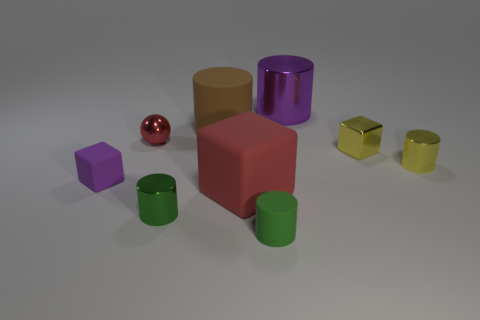Subtract all brown cylinders. How many cylinders are left? 4 Subtract all purple cylinders. How many cylinders are left? 4 Subtract all red cylinders. Subtract all yellow balls. How many cylinders are left? 5 Add 1 rubber cylinders. How many objects exist? 10 Subtract all blocks. How many objects are left? 6 Add 8 tiny spheres. How many tiny spheres exist? 9 Subtract 0 blue blocks. How many objects are left? 9 Subtract all small purple spheres. Subtract all purple matte cubes. How many objects are left? 8 Add 8 yellow objects. How many yellow objects are left? 10 